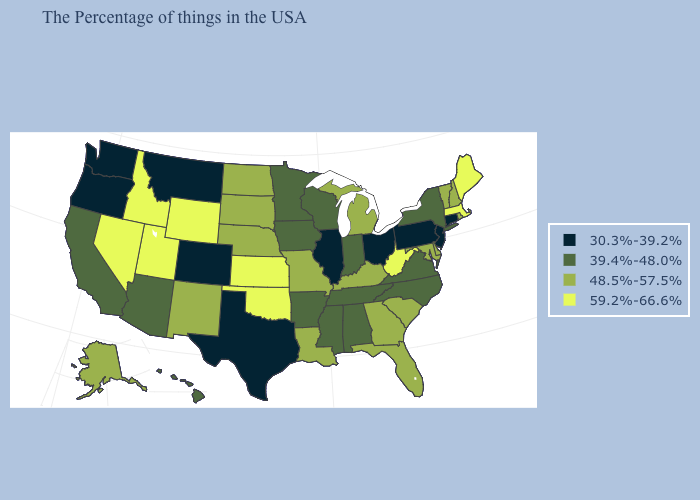What is the value of Utah?
Give a very brief answer. 59.2%-66.6%. What is the value of Texas?
Be succinct. 30.3%-39.2%. What is the value of Hawaii?
Answer briefly. 39.4%-48.0%. Which states have the lowest value in the South?
Write a very short answer. Texas. Which states have the lowest value in the South?
Keep it brief. Texas. Among the states that border Washington , which have the highest value?
Concise answer only. Idaho. What is the lowest value in states that border Connecticut?
Answer briefly. 39.4%-48.0%. What is the highest value in the MidWest ?
Answer briefly. 59.2%-66.6%. What is the lowest value in states that border South Carolina?
Give a very brief answer. 39.4%-48.0%. Does Texas have the highest value in the South?
Be succinct. No. Does Pennsylvania have the lowest value in the Northeast?
Concise answer only. Yes. What is the value of Oregon?
Give a very brief answer. 30.3%-39.2%. What is the value of Georgia?
Short answer required. 48.5%-57.5%. What is the value of New Mexico?
Keep it brief. 48.5%-57.5%. Does Arizona have the highest value in the West?
Write a very short answer. No. 